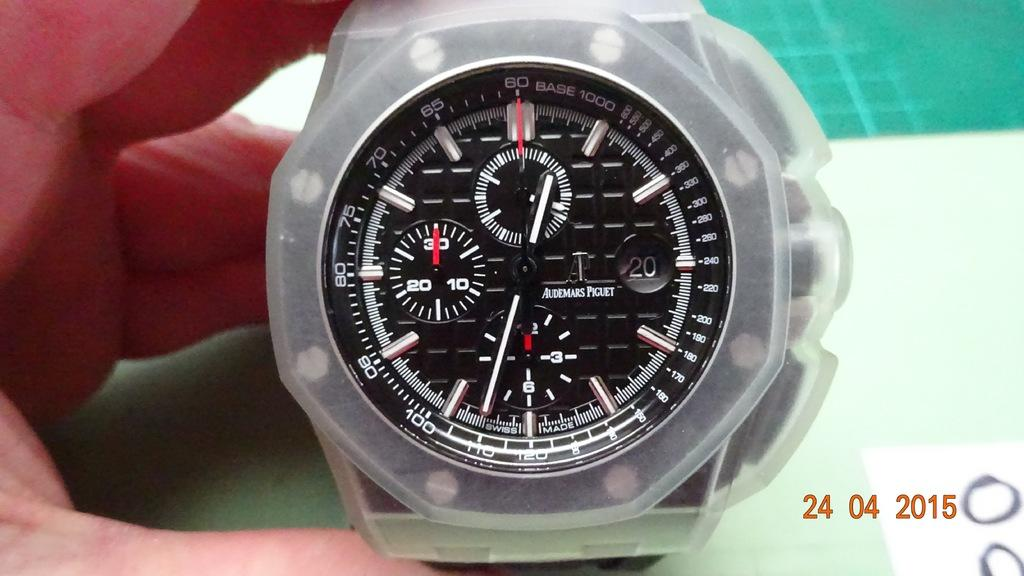<image>
Relay a brief, clear account of the picture shown. Person holding a stopwatch which says Audemars Piguet on the face. 